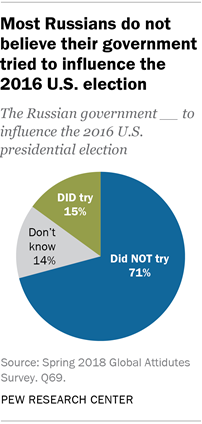List a handful of essential elements in this visual. The color of the "Did Not Try" segment of the graph is blue. The smallest two segments of the graph have a difference in value of 1. 